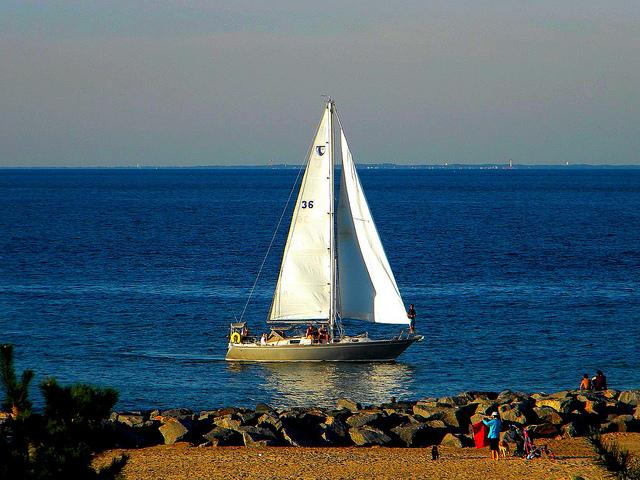How many sails are attached to the boat in the ocean?

Choices:
A) three
B) twentyeight
C) two
D) sixteen two 